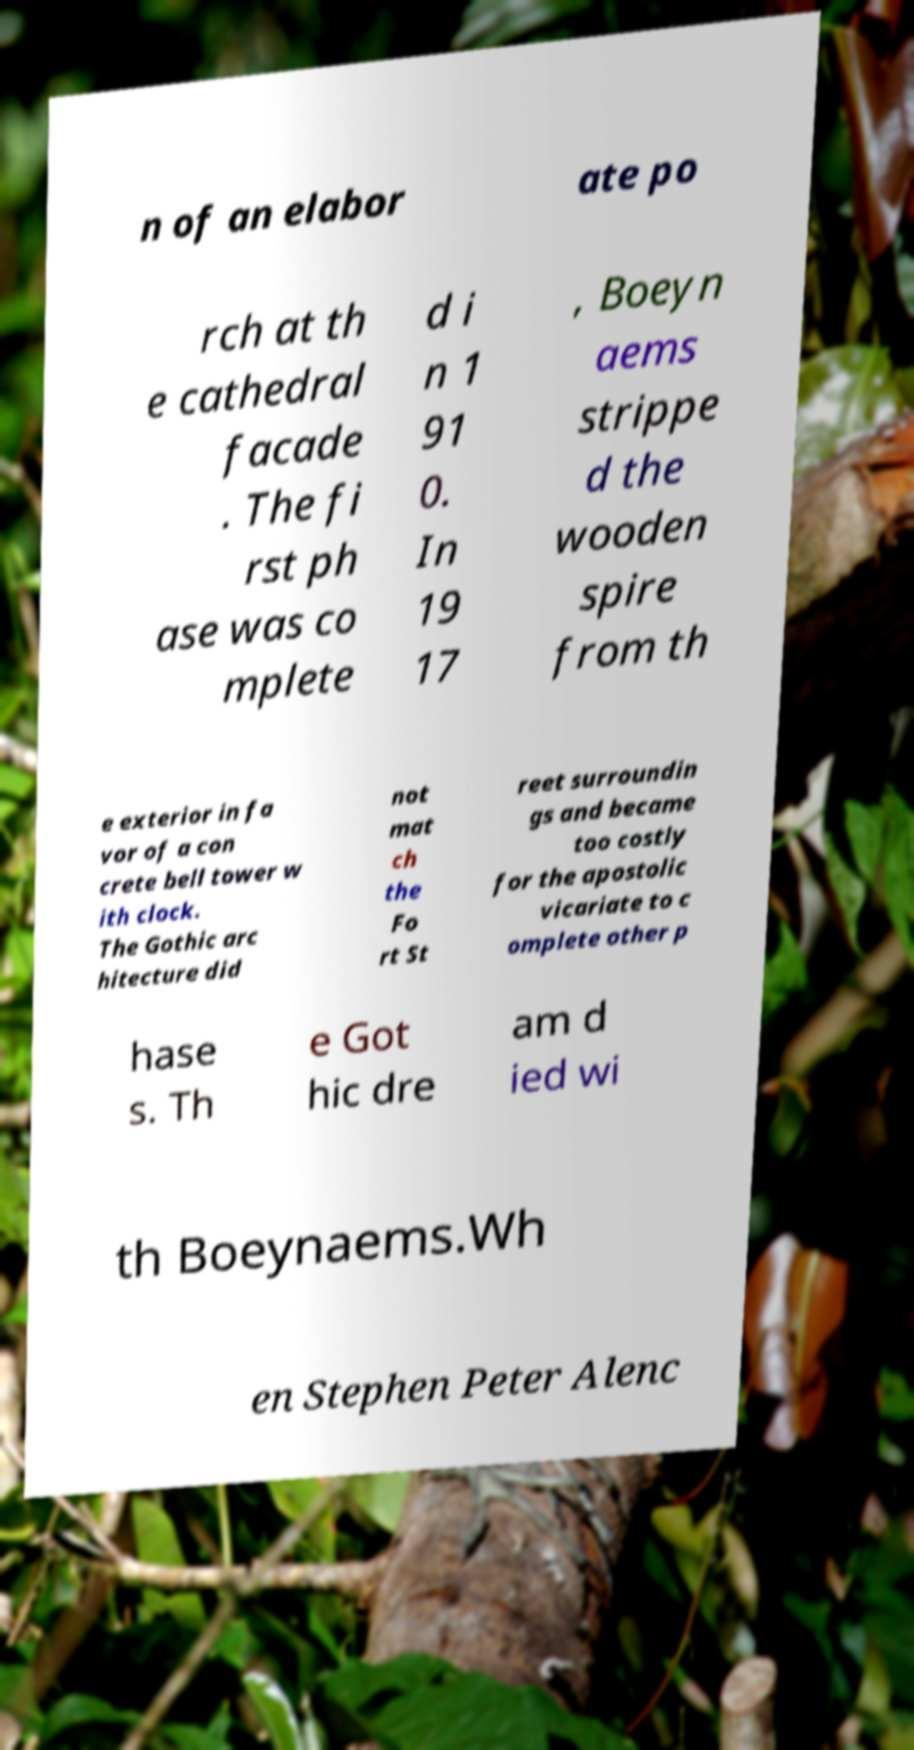For documentation purposes, I need the text within this image transcribed. Could you provide that? n of an elabor ate po rch at th e cathedral facade . The fi rst ph ase was co mplete d i n 1 91 0. In 19 17 , Boeyn aems strippe d the wooden spire from th e exterior in fa vor of a con crete bell tower w ith clock. The Gothic arc hitecture did not mat ch the Fo rt St reet surroundin gs and became too costly for the apostolic vicariate to c omplete other p hase s. Th e Got hic dre am d ied wi th Boeynaems.Wh en Stephen Peter Alenc 